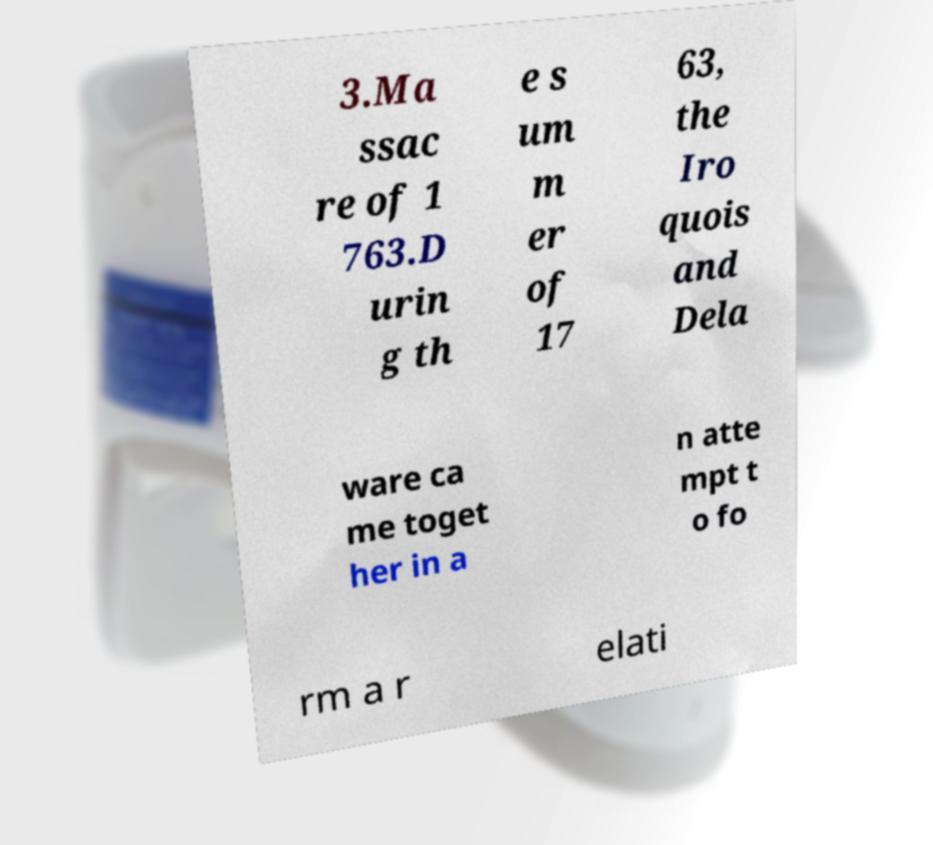I need the written content from this picture converted into text. Can you do that? 3.Ma ssac re of 1 763.D urin g th e s um m er of 17 63, the Iro quois and Dela ware ca me toget her in a n atte mpt t o fo rm a r elati 